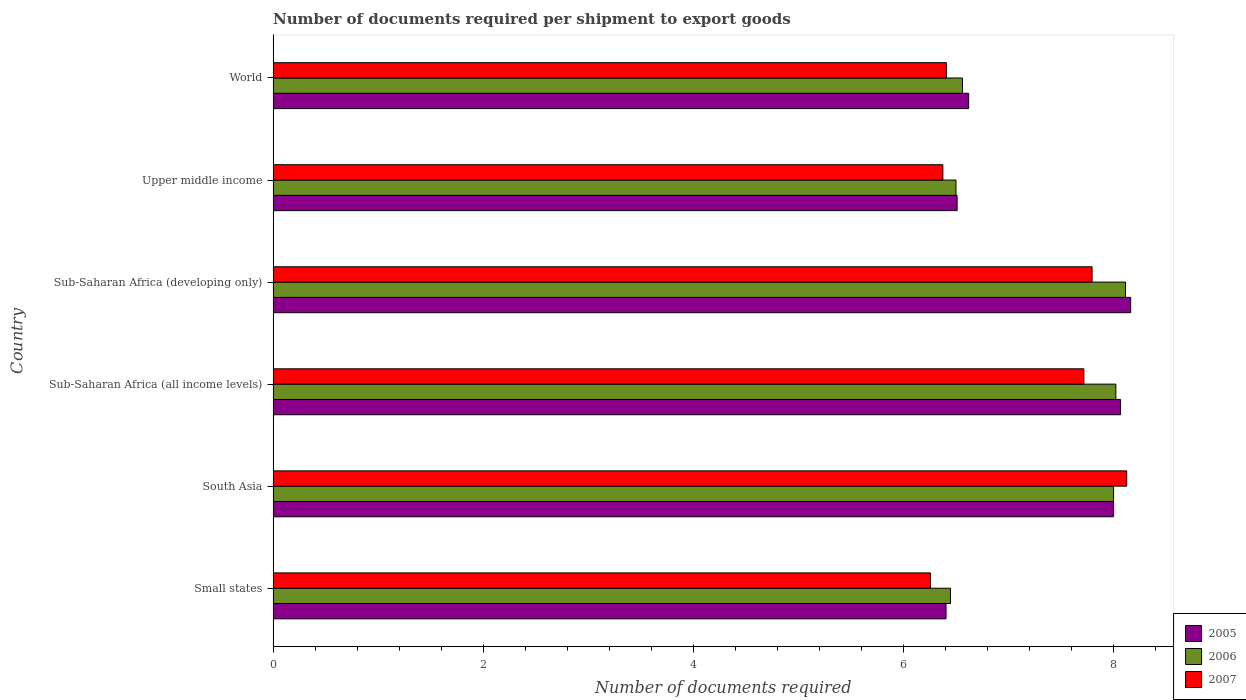How many different coloured bars are there?
Provide a short and direct response. 3. How many groups of bars are there?
Your answer should be compact. 6. Are the number of bars per tick equal to the number of legend labels?
Offer a terse response. Yes. Are the number of bars on each tick of the Y-axis equal?
Offer a terse response. Yes. What is the label of the 2nd group of bars from the top?
Your answer should be very brief. Upper middle income. What is the number of documents required per shipment to export goods in 2007 in Sub-Saharan Africa (developing only)?
Provide a short and direct response. 7.8. Across all countries, what is the maximum number of documents required per shipment to export goods in 2005?
Offer a very short reply. 8.16. Across all countries, what is the minimum number of documents required per shipment to export goods in 2007?
Your answer should be compact. 6.26. In which country was the number of documents required per shipment to export goods in 2007 maximum?
Make the answer very short. South Asia. In which country was the number of documents required per shipment to export goods in 2005 minimum?
Your response must be concise. Small states. What is the total number of documents required per shipment to export goods in 2006 in the graph?
Provide a succinct answer. 43.64. What is the difference between the number of documents required per shipment to export goods in 2006 in South Asia and the number of documents required per shipment to export goods in 2007 in World?
Offer a very short reply. 1.59. What is the average number of documents required per shipment to export goods in 2005 per country?
Keep it short and to the point. 7.29. What is the ratio of the number of documents required per shipment to export goods in 2005 in Small states to that in Upper middle income?
Your answer should be compact. 0.98. Is the number of documents required per shipment to export goods in 2007 in Sub-Saharan Africa (all income levels) less than that in Sub-Saharan Africa (developing only)?
Your answer should be very brief. Yes. What is the difference between the highest and the second highest number of documents required per shipment to export goods in 2007?
Your answer should be very brief. 0.33. What is the difference between the highest and the lowest number of documents required per shipment to export goods in 2005?
Provide a succinct answer. 1.76. What does the 3rd bar from the top in South Asia represents?
Your answer should be compact. 2005. Is it the case that in every country, the sum of the number of documents required per shipment to export goods in 2007 and number of documents required per shipment to export goods in 2006 is greater than the number of documents required per shipment to export goods in 2005?
Your answer should be compact. Yes. Are the values on the major ticks of X-axis written in scientific E-notation?
Provide a short and direct response. No. Does the graph contain any zero values?
Your answer should be compact. No. Where does the legend appear in the graph?
Your answer should be very brief. Bottom right. How many legend labels are there?
Your answer should be very brief. 3. How are the legend labels stacked?
Ensure brevity in your answer.  Vertical. What is the title of the graph?
Offer a terse response. Number of documents required per shipment to export goods. What is the label or title of the X-axis?
Offer a terse response. Number of documents required. What is the label or title of the Y-axis?
Ensure brevity in your answer.  Country. What is the Number of documents required of 2005 in Small states?
Your response must be concise. 6.41. What is the Number of documents required in 2006 in Small states?
Provide a short and direct response. 6.45. What is the Number of documents required in 2007 in Small states?
Offer a terse response. 6.26. What is the Number of documents required in 2005 in South Asia?
Keep it short and to the point. 8. What is the Number of documents required in 2006 in South Asia?
Offer a terse response. 8. What is the Number of documents required of 2007 in South Asia?
Provide a succinct answer. 8.12. What is the Number of documents required in 2005 in Sub-Saharan Africa (all income levels)?
Provide a succinct answer. 8.07. What is the Number of documents required of 2006 in Sub-Saharan Africa (all income levels)?
Offer a terse response. 8.02. What is the Number of documents required in 2007 in Sub-Saharan Africa (all income levels)?
Provide a short and direct response. 7.72. What is the Number of documents required of 2005 in Sub-Saharan Africa (developing only)?
Keep it short and to the point. 8.16. What is the Number of documents required of 2006 in Sub-Saharan Africa (developing only)?
Provide a short and direct response. 8.11. What is the Number of documents required in 2007 in Sub-Saharan Africa (developing only)?
Ensure brevity in your answer.  7.8. What is the Number of documents required in 2005 in Upper middle income?
Keep it short and to the point. 6.51. What is the Number of documents required in 2007 in Upper middle income?
Provide a short and direct response. 6.38. What is the Number of documents required in 2005 in World?
Offer a very short reply. 6.62. What is the Number of documents required in 2006 in World?
Keep it short and to the point. 6.56. What is the Number of documents required in 2007 in World?
Give a very brief answer. 6.41. Across all countries, what is the maximum Number of documents required in 2005?
Give a very brief answer. 8.16. Across all countries, what is the maximum Number of documents required in 2006?
Ensure brevity in your answer.  8.11. Across all countries, what is the maximum Number of documents required in 2007?
Your answer should be very brief. 8.12. Across all countries, what is the minimum Number of documents required in 2005?
Ensure brevity in your answer.  6.41. Across all countries, what is the minimum Number of documents required in 2006?
Provide a short and direct response. 6.45. Across all countries, what is the minimum Number of documents required in 2007?
Make the answer very short. 6.26. What is the total Number of documents required in 2005 in the graph?
Ensure brevity in your answer.  43.77. What is the total Number of documents required of 2006 in the graph?
Ensure brevity in your answer.  43.64. What is the total Number of documents required in 2007 in the graph?
Your response must be concise. 42.68. What is the difference between the Number of documents required of 2005 in Small states and that in South Asia?
Your response must be concise. -1.59. What is the difference between the Number of documents required of 2006 in Small states and that in South Asia?
Ensure brevity in your answer.  -1.55. What is the difference between the Number of documents required in 2007 in Small states and that in South Asia?
Offer a terse response. -1.87. What is the difference between the Number of documents required of 2005 in Small states and that in Sub-Saharan Africa (all income levels)?
Give a very brief answer. -1.66. What is the difference between the Number of documents required of 2006 in Small states and that in Sub-Saharan Africa (all income levels)?
Keep it short and to the point. -1.57. What is the difference between the Number of documents required in 2007 in Small states and that in Sub-Saharan Africa (all income levels)?
Make the answer very short. -1.46. What is the difference between the Number of documents required in 2005 in Small states and that in Sub-Saharan Africa (developing only)?
Provide a short and direct response. -1.76. What is the difference between the Number of documents required of 2006 in Small states and that in Sub-Saharan Africa (developing only)?
Give a very brief answer. -1.67. What is the difference between the Number of documents required of 2007 in Small states and that in Sub-Saharan Africa (developing only)?
Your answer should be very brief. -1.54. What is the difference between the Number of documents required in 2005 in Small states and that in Upper middle income?
Provide a succinct answer. -0.11. What is the difference between the Number of documents required in 2006 in Small states and that in Upper middle income?
Your response must be concise. -0.05. What is the difference between the Number of documents required of 2007 in Small states and that in Upper middle income?
Your answer should be very brief. -0.12. What is the difference between the Number of documents required of 2005 in Small states and that in World?
Give a very brief answer. -0.22. What is the difference between the Number of documents required in 2006 in Small states and that in World?
Keep it short and to the point. -0.11. What is the difference between the Number of documents required in 2007 in Small states and that in World?
Offer a terse response. -0.15. What is the difference between the Number of documents required of 2005 in South Asia and that in Sub-Saharan Africa (all income levels)?
Offer a very short reply. -0.07. What is the difference between the Number of documents required in 2006 in South Asia and that in Sub-Saharan Africa (all income levels)?
Offer a terse response. -0.02. What is the difference between the Number of documents required of 2007 in South Asia and that in Sub-Saharan Africa (all income levels)?
Provide a succinct answer. 0.41. What is the difference between the Number of documents required in 2005 in South Asia and that in Sub-Saharan Africa (developing only)?
Your response must be concise. -0.16. What is the difference between the Number of documents required in 2006 in South Asia and that in Sub-Saharan Africa (developing only)?
Provide a short and direct response. -0.11. What is the difference between the Number of documents required of 2007 in South Asia and that in Sub-Saharan Africa (developing only)?
Make the answer very short. 0.33. What is the difference between the Number of documents required of 2005 in South Asia and that in Upper middle income?
Provide a short and direct response. 1.49. What is the difference between the Number of documents required of 2006 in South Asia and that in Upper middle income?
Your answer should be very brief. 1.5. What is the difference between the Number of documents required in 2007 in South Asia and that in Upper middle income?
Keep it short and to the point. 1.75. What is the difference between the Number of documents required in 2005 in South Asia and that in World?
Your answer should be compact. 1.38. What is the difference between the Number of documents required in 2006 in South Asia and that in World?
Make the answer very short. 1.44. What is the difference between the Number of documents required in 2007 in South Asia and that in World?
Ensure brevity in your answer.  1.72. What is the difference between the Number of documents required of 2005 in Sub-Saharan Africa (all income levels) and that in Sub-Saharan Africa (developing only)?
Ensure brevity in your answer.  -0.1. What is the difference between the Number of documents required of 2006 in Sub-Saharan Africa (all income levels) and that in Sub-Saharan Africa (developing only)?
Provide a short and direct response. -0.09. What is the difference between the Number of documents required in 2007 in Sub-Saharan Africa (all income levels) and that in Sub-Saharan Africa (developing only)?
Your answer should be very brief. -0.08. What is the difference between the Number of documents required of 2005 in Sub-Saharan Africa (all income levels) and that in Upper middle income?
Offer a very short reply. 1.56. What is the difference between the Number of documents required in 2006 in Sub-Saharan Africa (all income levels) and that in Upper middle income?
Offer a very short reply. 1.52. What is the difference between the Number of documents required in 2007 in Sub-Saharan Africa (all income levels) and that in Upper middle income?
Keep it short and to the point. 1.34. What is the difference between the Number of documents required of 2005 in Sub-Saharan Africa (all income levels) and that in World?
Ensure brevity in your answer.  1.45. What is the difference between the Number of documents required in 2006 in Sub-Saharan Africa (all income levels) and that in World?
Your answer should be compact. 1.46. What is the difference between the Number of documents required in 2007 in Sub-Saharan Africa (all income levels) and that in World?
Your answer should be very brief. 1.31. What is the difference between the Number of documents required of 2005 in Sub-Saharan Africa (developing only) and that in Upper middle income?
Keep it short and to the point. 1.65. What is the difference between the Number of documents required of 2006 in Sub-Saharan Africa (developing only) and that in Upper middle income?
Offer a terse response. 1.61. What is the difference between the Number of documents required in 2007 in Sub-Saharan Africa (developing only) and that in Upper middle income?
Offer a very short reply. 1.42. What is the difference between the Number of documents required of 2005 in Sub-Saharan Africa (developing only) and that in World?
Ensure brevity in your answer.  1.54. What is the difference between the Number of documents required in 2006 in Sub-Saharan Africa (developing only) and that in World?
Your answer should be compact. 1.55. What is the difference between the Number of documents required in 2007 in Sub-Saharan Africa (developing only) and that in World?
Give a very brief answer. 1.39. What is the difference between the Number of documents required in 2005 in Upper middle income and that in World?
Provide a short and direct response. -0.11. What is the difference between the Number of documents required of 2006 in Upper middle income and that in World?
Offer a very short reply. -0.06. What is the difference between the Number of documents required in 2007 in Upper middle income and that in World?
Provide a succinct answer. -0.03. What is the difference between the Number of documents required in 2005 in Small states and the Number of documents required in 2006 in South Asia?
Ensure brevity in your answer.  -1.59. What is the difference between the Number of documents required of 2005 in Small states and the Number of documents required of 2007 in South Asia?
Your response must be concise. -1.72. What is the difference between the Number of documents required in 2006 in Small states and the Number of documents required in 2007 in South Asia?
Give a very brief answer. -1.68. What is the difference between the Number of documents required of 2005 in Small states and the Number of documents required of 2006 in Sub-Saharan Africa (all income levels)?
Your response must be concise. -1.62. What is the difference between the Number of documents required of 2005 in Small states and the Number of documents required of 2007 in Sub-Saharan Africa (all income levels)?
Make the answer very short. -1.31. What is the difference between the Number of documents required of 2006 in Small states and the Number of documents required of 2007 in Sub-Saharan Africa (all income levels)?
Offer a terse response. -1.27. What is the difference between the Number of documents required in 2005 in Small states and the Number of documents required in 2006 in Sub-Saharan Africa (developing only)?
Make the answer very short. -1.71. What is the difference between the Number of documents required in 2005 in Small states and the Number of documents required in 2007 in Sub-Saharan Africa (developing only)?
Provide a succinct answer. -1.39. What is the difference between the Number of documents required in 2006 in Small states and the Number of documents required in 2007 in Sub-Saharan Africa (developing only)?
Ensure brevity in your answer.  -1.35. What is the difference between the Number of documents required in 2005 in Small states and the Number of documents required in 2006 in Upper middle income?
Your response must be concise. -0.09. What is the difference between the Number of documents required of 2005 in Small states and the Number of documents required of 2007 in Upper middle income?
Keep it short and to the point. 0.03. What is the difference between the Number of documents required of 2006 in Small states and the Number of documents required of 2007 in Upper middle income?
Provide a succinct answer. 0.07. What is the difference between the Number of documents required in 2005 in Small states and the Number of documents required in 2006 in World?
Provide a succinct answer. -0.16. What is the difference between the Number of documents required of 2005 in Small states and the Number of documents required of 2007 in World?
Provide a succinct answer. -0. What is the difference between the Number of documents required of 2006 in Small states and the Number of documents required of 2007 in World?
Keep it short and to the point. 0.04. What is the difference between the Number of documents required of 2005 in South Asia and the Number of documents required of 2006 in Sub-Saharan Africa (all income levels)?
Offer a very short reply. -0.02. What is the difference between the Number of documents required in 2005 in South Asia and the Number of documents required in 2007 in Sub-Saharan Africa (all income levels)?
Offer a terse response. 0.28. What is the difference between the Number of documents required of 2006 in South Asia and the Number of documents required of 2007 in Sub-Saharan Africa (all income levels)?
Offer a very short reply. 0.28. What is the difference between the Number of documents required of 2005 in South Asia and the Number of documents required of 2006 in Sub-Saharan Africa (developing only)?
Your answer should be very brief. -0.11. What is the difference between the Number of documents required in 2005 in South Asia and the Number of documents required in 2007 in Sub-Saharan Africa (developing only)?
Your answer should be very brief. 0.2. What is the difference between the Number of documents required of 2006 in South Asia and the Number of documents required of 2007 in Sub-Saharan Africa (developing only)?
Make the answer very short. 0.2. What is the difference between the Number of documents required in 2005 in South Asia and the Number of documents required in 2007 in Upper middle income?
Provide a succinct answer. 1.62. What is the difference between the Number of documents required in 2006 in South Asia and the Number of documents required in 2007 in Upper middle income?
Keep it short and to the point. 1.62. What is the difference between the Number of documents required in 2005 in South Asia and the Number of documents required in 2006 in World?
Give a very brief answer. 1.44. What is the difference between the Number of documents required in 2005 in South Asia and the Number of documents required in 2007 in World?
Offer a very short reply. 1.59. What is the difference between the Number of documents required in 2006 in South Asia and the Number of documents required in 2007 in World?
Your answer should be compact. 1.59. What is the difference between the Number of documents required of 2005 in Sub-Saharan Africa (all income levels) and the Number of documents required of 2006 in Sub-Saharan Africa (developing only)?
Your answer should be compact. -0.05. What is the difference between the Number of documents required of 2005 in Sub-Saharan Africa (all income levels) and the Number of documents required of 2007 in Sub-Saharan Africa (developing only)?
Make the answer very short. 0.27. What is the difference between the Number of documents required in 2006 in Sub-Saharan Africa (all income levels) and the Number of documents required in 2007 in Sub-Saharan Africa (developing only)?
Your answer should be very brief. 0.23. What is the difference between the Number of documents required of 2005 in Sub-Saharan Africa (all income levels) and the Number of documents required of 2006 in Upper middle income?
Give a very brief answer. 1.57. What is the difference between the Number of documents required in 2005 in Sub-Saharan Africa (all income levels) and the Number of documents required in 2007 in Upper middle income?
Make the answer very short. 1.69. What is the difference between the Number of documents required in 2006 in Sub-Saharan Africa (all income levels) and the Number of documents required in 2007 in Upper middle income?
Make the answer very short. 1.65. What is the difference between the Number of documents required of 2005 in Sub-Saharan Africa (all income levels) and the Number of documents required of 2006 in World?
Offer a terse response. 1.5. What is the difference between the Number of documents required in 2005 in Sub-Saharan Africa (all income levels) and the Number of documents required in 2007 in World?
Offer a very short reply. 1.66. What is the difference between the Number of documents required in 2006 in Sub-Saharan Africa (all income levels) and the Number of documents required in 2007 in World?
Your response must be concise. 1.61. What is the difference between the Number of documents required of 2005 in Sub-Saharan Africa (developing only) and the Number of documents required of 2006 in Upper middle income?
Your answer should be very brief. 1.66. What is the difference between the Number of documents required of 2005 in Sub-Saharan Africa (developing only) and the Number of documents required of 2007 in Upper middle income?
Offer a terse response. 1.79. What is the difference between the Number of documents required of 2006 in Sub-Saharan Africa (developing only) and the Number of documents required of 2007 in Upper middle income?
Give a very brief answer. 1.74. What is the difference between the Number of documents required of 2005 in Sub-Saharan Africa (developing only) and the Number of documents required of 2006 in World?
Your response must be concise. 1.6. What is the difference between the Number of documents required in 2005 in Sub-Saharan Africa (developing only) and the Number of documents required in 2007 in World?
Your answer should be very brief. 1.75. What is the difference between the Number of documents required of 2006 in Sub-Saharan Africa (developing only) and the Number of documents required of 2007 in World?
Keep it short and to the point. 1.7. What is the difference between the Number of documents required of 2005 in Upper middle income and the Number of documents required of 2006 in World?
Your answer should be very brief. -0.05. What is the difference between the Number of documents required in 2005 in Upper middle income and the Number of documents required in 2007 in World?
Keep it short and to the point. 0.1. What is the difference between the Number of documents required in 2006 in Upper middle income and the Number of documents required in 2007 in World?
Your answer should be very brief. 0.09. What is the average Number of documents required of 2005 per country?
Keep it short and to the point. 7.29. What is the average Number of documents required of 2006 per country?
Offer a terse response. 7.27. What is the average Number of documents required in 2007 per country?
Offer a very short reply. 7.11. What is the difference between the Number of documents required of 2005 and Number of documents required of 2006 in Small states?
Your response must be concise. -0.04. What is the difference between the Number of documents required in 2005 and Number of documents required in 2007 in Small states?
Your answer should be compact. 0.15. What is the difference between the Number of documents required of 2006 and Number of documents required of 2007 in Small states?
Make the answer very short. 0.19. What is the difference between the Number of documents required of 2005 and Number of documents required of 2007 in South Asia?
Provide a succinct answer. -0.12. What is the difference between the Number of documents required of 2006 and Number of documents required of 2007 in South Asia?
Give a very brief answer. -0.12. What is the difference between the Number of documents required of 2005 and Number of documents required of 2006 in Sub-Saharan Africa (all income levels)?
Offer a terse response. 0.04. What is the difference between the Number of documents required of 2005 and Number of documents required of 2007 in Sub-Saharan Africa (all income levels)?
Offer a terse response. 0.35. What is the difference between the Number of documents required of 2006 and Number of documents required of 2007 in Sub-Saharan Africa (all income levels)?
Your answer should be very brief. 0.3. What is the difference between the Number of documents required of 2005 and Number of documents required of 2006 in Sub-Saharan Africa (developing only)?
Your answer should be compact. 0.05. What is the difference between the Number of documents required in 2005 and Number of documents required in 2007 in Sub-Saharan Africa (developing only)?
Keep it short and to the point. 0.37. What is the difference between the Number of documents required of 2006 and Number of documents required of 2007 in Sub-Saharan Africa (developing only)?
Offer a terse response. 0.32. What is the difference between the Number of documents required of 2005 and Number of documents required of 2006 in Upper middle income?
Offer a terse response. 0.01. What is the difference between the Number of documents required of 2005 and Number of documents required of 2007 in Upper middle income?
Provide a succinct answer. 0.14. What is the difference between the Number of documents required in 2005 and Number of documents required in 2006 in World?
Provide a succinct answer. 0.06. What is the difference between the Number of documents required of 2005 and Number of documents required of 2007 in World?
Give a very brief answer. 0.21. What is the difference between the Number of documents required of 2006 and Number of documents required of 2007 in World?
Provide a short and direct response. 0.15. What is the ratio of the Number of documents required in 2005 in Small states to that in South Asia?
Offer a terse response. 0.8. What is the ratio of the Number of documents required in 2006 in Small states to that in South Asia?
Offer a very short reply. 0.81. What is the ratio of the Number of documents required of 2007 in Small states to that in South Asia?
Keep it short and to the point. 0.77. What is the ratio of the Number of documents required in 2005 in Small states to that in Sub-Saharan Africa (all income levels)?
Provide a short and direct response. 0.79. What is the ratio of the Number of documents required in 2006 in Small states to that in Sub-Saharan Africa (all income levels)?
Keep it short and to the point. 0.8. What is the ratio of the Number of documents required in 2007 in Small states to that in Sub-Saharan Africa (all income levels)?
Ensure brevity in your answer.  0.81. What is the ratio of the Number of documents required of 2005 in Small states to that in Sub-Saharan Africa (developing only)?
Your answer should be very brief. 0.78. What is the ratio of the Number of documents required of 2006 in Small states to that in Sub-Saharan Africa (developing only)?
Offer a terse response. 0.79. What is the ratio of the Number of documents required of 2007 in Small states to that in Sub-Saharan Africa (developing only)?
Your answer should be very brief. 0.8. What is the ratio of the Number of documents required of 2005 in Small states to that in Upper middle income?
Ensure brevity in your answer.  0.98. What is the ratio of the Number of documents required in 2006 in Small states to that in Upper middle income?
Make the answer very short. 0.99. What is the ratio of the Number of documents required of 2007 in Small states to that in Upper middle income?
Your answer should be very brief. 0.98. What is the ratio of the Number of documents required of 2005 in Small states to that in World?
Provide a succinct answer. 0.97. What is the ratio of the Number of documents required of 2006 in Small states to that in World?
Keep it short and to the point. 0.98. What is the ratio of the Number of documents required of 2007 in Small states to that in World?
Provide a short and direct response. 0.98. What is the ratio of the Number of documents required of 2005 in South Asia to that in Sub-Saharan Africa (all income levels)?
Offer a very short reply. 0.99. What is the ratio of the Number of documents required of 2007 in South Asia to that in Sub-Saharan Africa (all income levels)?
Keep it short and to the point. 1.05. What is the ratio of the Number of documents required of 2005 in South Asia to that in Sub-Saharan Africa (developing only)?
Give a very brief answer. 0.98. What is the ratio of the Number of documents required in 2007 in South Asia to that in Sub-Saharan Africa (developing only)?
Make the answer very short. 1.04. What is the ratio of the Number of documents required of 2005 in South Asia to that in Upper middle income?
Provide a succinct answer. 1.23. What is the ratio of the Number of documents required of 2006 in South Asia to that in Upper middle income?
Make the answer very short. 1.23. What is the ratio of the Number of documents required of 2007 in South Asia to that in Upper middle income?
Provide a succinct answer. 1.27. What is the ratio of the Number of documents required of 2005 in South Asia to that in World?
Provide a succinct answer. 1.21. What is the ratio of the Number of documents required in 2006 in South Asia to that in World?
Your answer should be compact. 1.22. What is the ratio of the Number of documents required of 2007 in South Asia to that in World?
Give a very brief answer. 1.27. What is the ratio of the Number of documents required in 2006 in Sub-Saharan Africa (all income levels) to that in Sub-Saharan Africa (developing only)?
Provide a succinct answer. 0.99. What is the ratio of the Number of documents required in 2005 in Sub-Saharan Africa (all income levels) to that in Upper middle income?
Provide a short and direct response. 1.24. What is the ratio of the Number of documents required in 2006 in Sub-Saharan Africa (all income levels) to that in Upper middle income?
Your response must be concise. 1.23. What is the ratio of the Number of documents required of 2007 in Sub-Saharan Africa (all income levels) to that in Upper middle income?
Provide a succinct answer. 1.21. What is the ratio of the Number of documents required in 2005 in Sub-Saharan Africa (all income levels) to that in World?
Give a very brief answer. 1.22. What is the ratio of the Number of documents required in 2006 in Sub-Saharan Africa (all income levels) to that in World?
Provide a succinct answer. 1.22. What is the ratio of the Number of documents required in 2007 in Sub-Saharan Africa (all income levels) to that in World?
Provide a succinct answer. 1.2. What is the ratio of the Number of documents required in 2005 in Sub-Saharan Africa (developing only) to that in Upper middle income?
Offer a very short reply. 1.25. What is the ratio of the Number of documents required of 2006 in Sub-Saharan Africa (developing only) to that in Upper middle income?
Your answer should be compact. 1.25. What is the ratio of the Number of documents required of 2007 in Sub-Saharan Africa (developing only) to that in Upper middle income?
Your answer should be very brief. 1.22. What is the ratio of the Number of documents required of 2005 in Sub-Saharan Africa (developing only) to that in World?
Make the answer very short. 1.23. What is the ratio of the Number of documents required in 2006 in Sub-Saharan Africa (developing only) to that in World?
Give a very brief answer. 1.24. What is the ratio of the Number of documents required in 2007 in Sub-Saharan Africa (developing only) to that in World?
Ensure brevity in your answer.  1.22. What is the ratio of the Number of documents required in 2005 in Upper middle income to that in World?
Your answer should be very brief. 0.98. What is the ratio of the Number of documents required in 2006 in Upper middle income to that in World?
Your answer should be compact. 0.99. What is the ratio of the Number of documents required in 2007 in Upper middle income to that in World?
Ensure brevity in your answer.  0.99. What is the difference between the highest and the second highest Number of documents required in 2005?
Your answer should be very brief. 0.1. What is the difference between the highest and the second highest Number of documents required in 2006?
Provide a short and direct response. 0.09. What is the difference between the highest and the second highest Number of documents required of 2007?
Give a very brief answer. 0.33. What is the difference between the highest and the lowest Number of documents required of 2005?
Provide a succinct answer. 1.76. What is the difference between the highest and the lowest Number of documents required in 2006?
Provide a succinct answer. 1.67. What is the difference between the highest and the lowest Number of documents required in 2007?
Your answer should be compact. 1.87. 